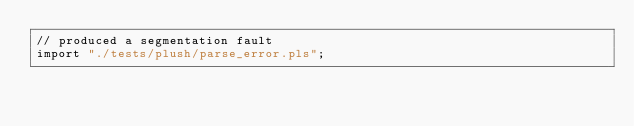Convert code to text. <code><loc_0><loc_0><loc_500><loc_500><_SQL_>// produced a segmentation fault
import "./tests/plush/parse_error.pls";
</code> 